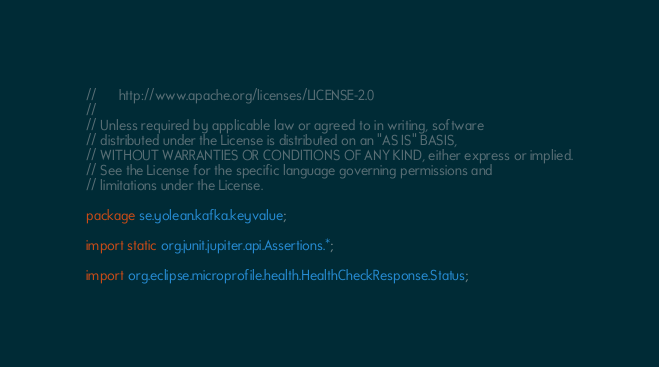<code> <loc_0><loc_0><loc_500><loc_500><_Java_>//      http://www.apache.org/licenses/LICENSE-2.0
//
// Unless required by applicable law or agreed to in writing, software
// distributed under the License is distributed on an "AS IS" BASIS,
// WITHOUT WARRANTIES OR CONDITIONS OF ANY KIND, either express or implied.
// See the License for the specific language governing permissions and
// limitations under the License.

package se.yolean.kafka.keyvalue;

import static org.junit.jupiter.api.Assertions.*;

import org.eclipse.microprofile.health.HealthCheckResponse.Status;</code> 